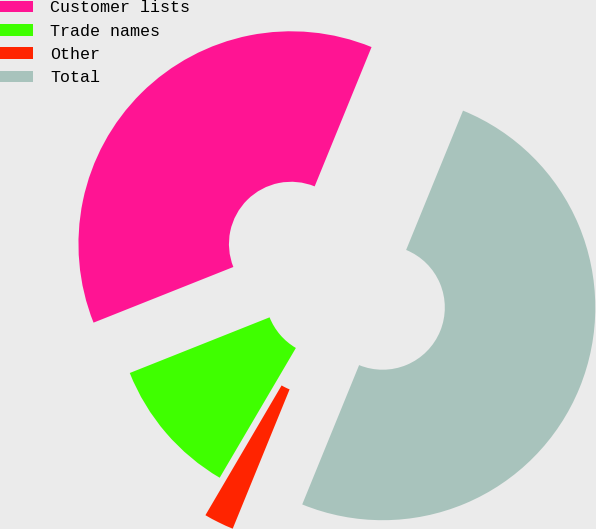Convert chart. <chart><loc_0><loc_0><loc_500><loc_500><pie_chart><fcel>Customer lists<fcel>Trade names<fcel>Other<fcel>Total<nl><fcel>37.2%<fcel>10.52%<fcel>2.28%<fcel>50.0%<nl></chart> 